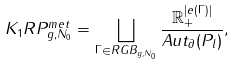<formula> <loc_0><loc_0><loc_500><loc_500>K _ { 1 } R P _ { g , N _ { 0 } } ^ { m e t } = \bigsqcup _ { \Gamma \in R G B _ { g , N _ { 0 } } } \frac { \mathbb { R } _ { + } ^ { | e ( \Gamma ) | } } { A u t _ { \partial } ( P _ { l } ) } ,</formula> 